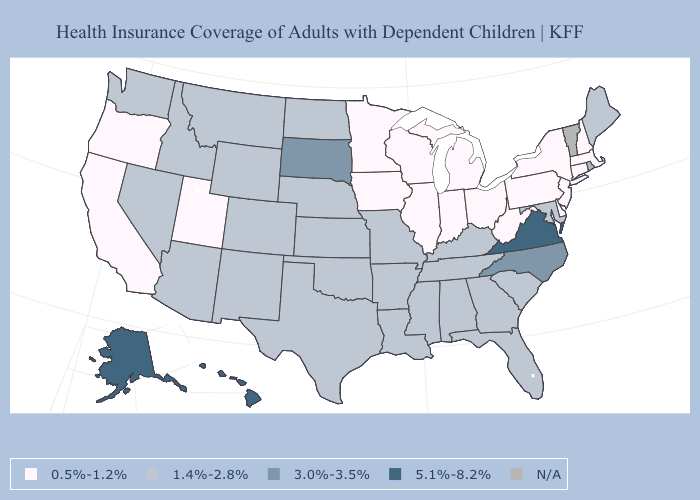Name the states that have a value in the range 0.5%-1.2%?
Quick response, please. California, Connecticut, Delaware, Illinois, Indiana, Iowa, Massachusetts, Michigan, Minnesota, New Hampshire, New Jersey, New York, Ohio, Oregon, Pennsylvania, Utah, West Virginia, Wisconsin. What is the lowest value in the Northeast?
Write a very short answer. 0.5%-1.2%. Among the states that border Colorado , does Arizona have the highest value?
Short answer required. Yes. Name the states that have a value in the range 5.1%-8.2%?
Give a very brief answer. Alaska, Hawaii, Virginia. Among the states that border Georgia , does North Carolina have the lowest value?
Give a very brief answer. No. What is the value of Vermont?
Answer briefly. N/A. What is the value of Georgia?
Short answer required. 1.4%-2.8%. What is the highest value in states that border Maine?
Write a very short answer. 0.5%-1.2%. Which states have the highest value in the USA?
Write a very short answer. Alaska, Hawaii, Virginia. Does the map have missing data?
Short answer required. Yes. What is the value of Missouri?
Answer briefly. 1.4%-2.8%. Among the states that border Florida , which have the lowest value?
Concise answer only. Alabama, Georgia. Name the states that have a value in the range 3.0%-3.5%?
Give a very brief answer. North Carolina, South Dakota. Name the states that have a value in the range N/A?
Give a very brief answer. Rhode Island, Vermont. Does Hawaii have the highest value in the West?
Quick response, please. Yes. 